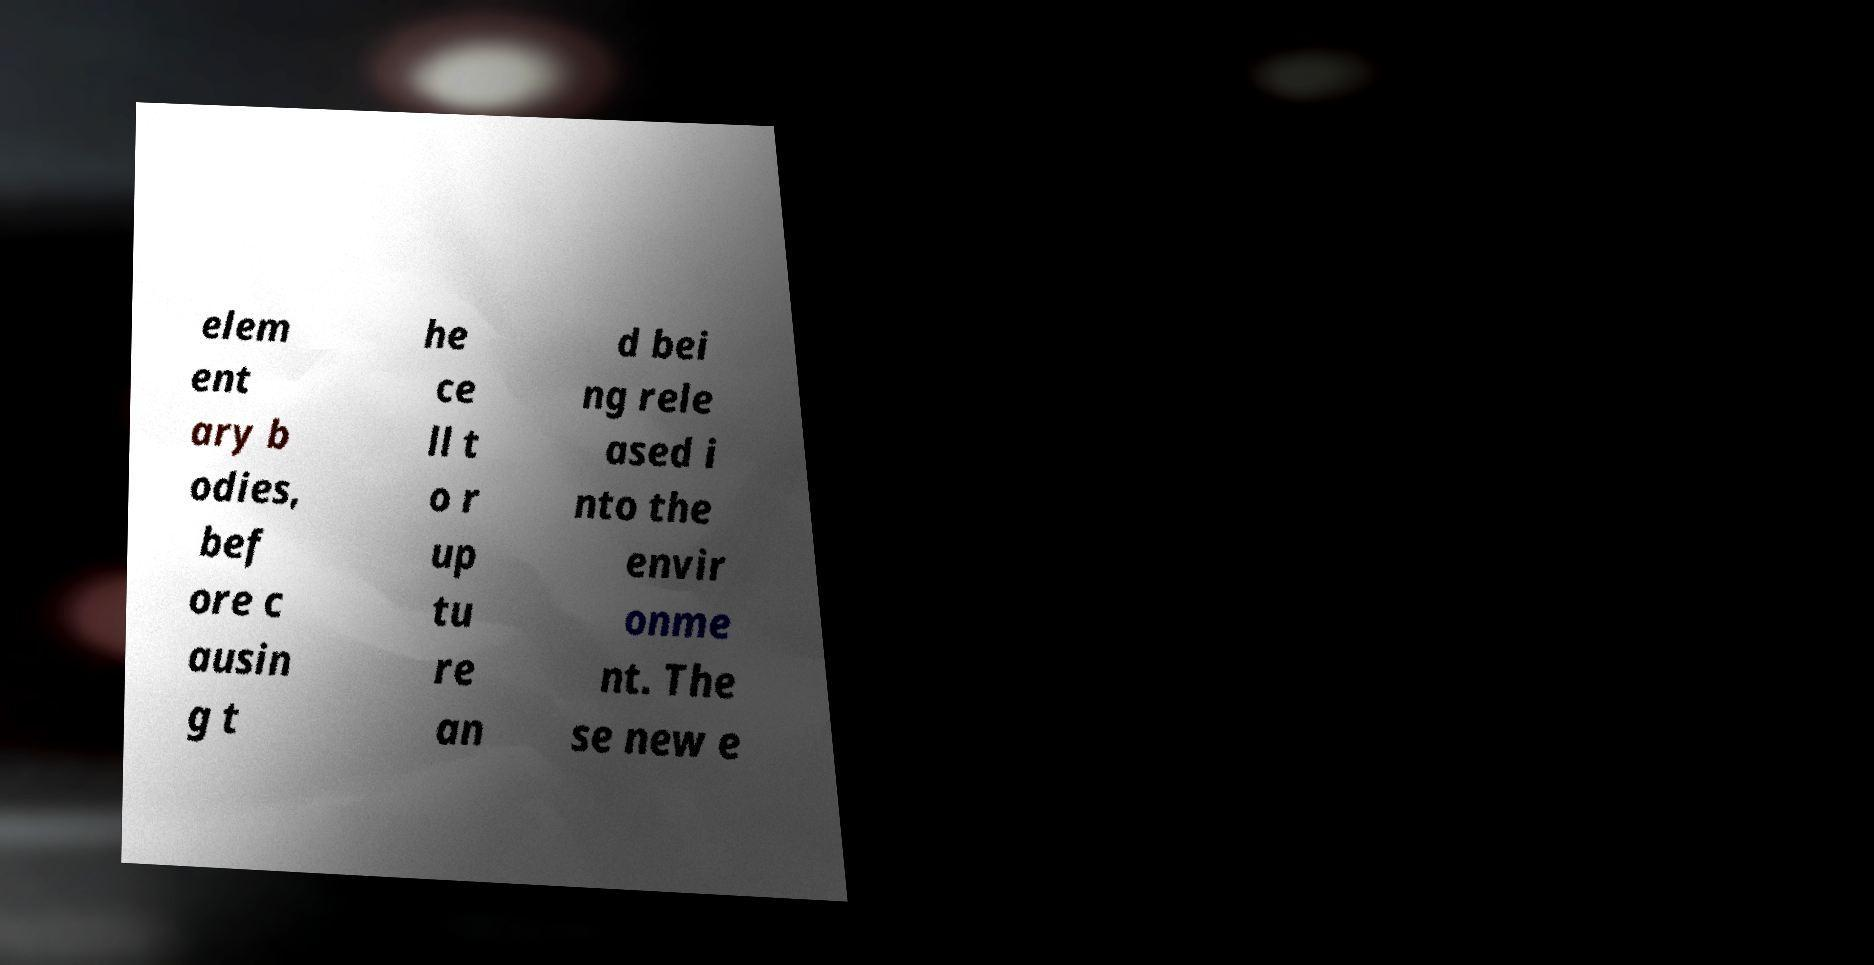There's text embedded in this image that I need extracted. Can you transcribe it verbatim? elem ent ary b odies, bef ore c ausin g t he ce ll t o r up tu re an d bei ng rele ased i nto the envir onme nt. The se new e 